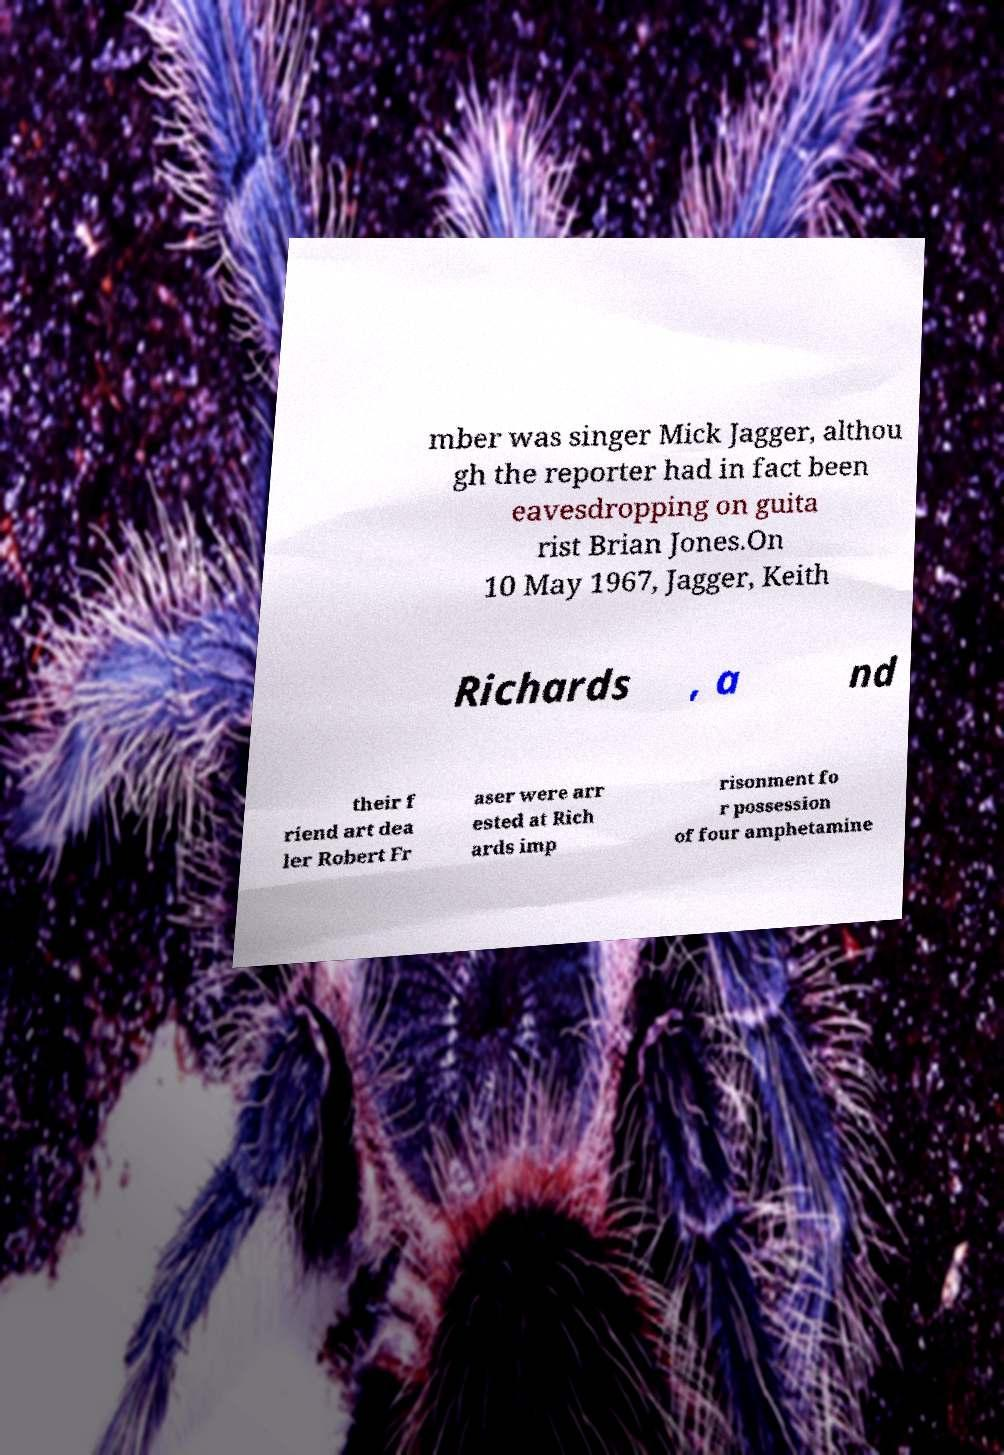Could you extract and type out the text from this image? mber was singer Mick Jagger, althou gh the reporter had in fact been eavesdropping on guita rist Brian Jones.On 10 May 1967, Jagger, Keith Richards , a nd their f riend art dea ler Robert Fr aser were arr ested at Rich ards imp risonment fo r possession of four amphetamine 